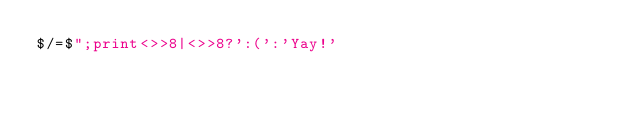Convert code to text. <code><loc_0><loc_0><loc_500><loc_500><_Perl_>$/=$";print<>>8|<>>8?':(':'Yay!'</code> 